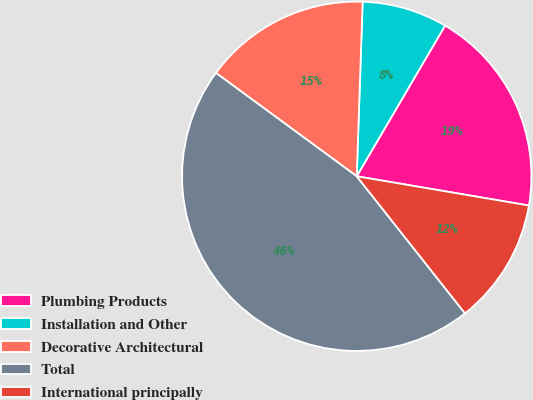Convert chart to OTSL. <chart><loc_0><loc_0><loc_500><loc_500><pie_chart><fcel>Plumbing Products<fcel>Installation and Other<fcel>Decorative Architectural<fcel>Total<fcel>International principally<nl><fcel>19.24%<fcel>7.9%<fcel>15.46%<fcel>45.72%<fcel>11.68%<nl></chart> 